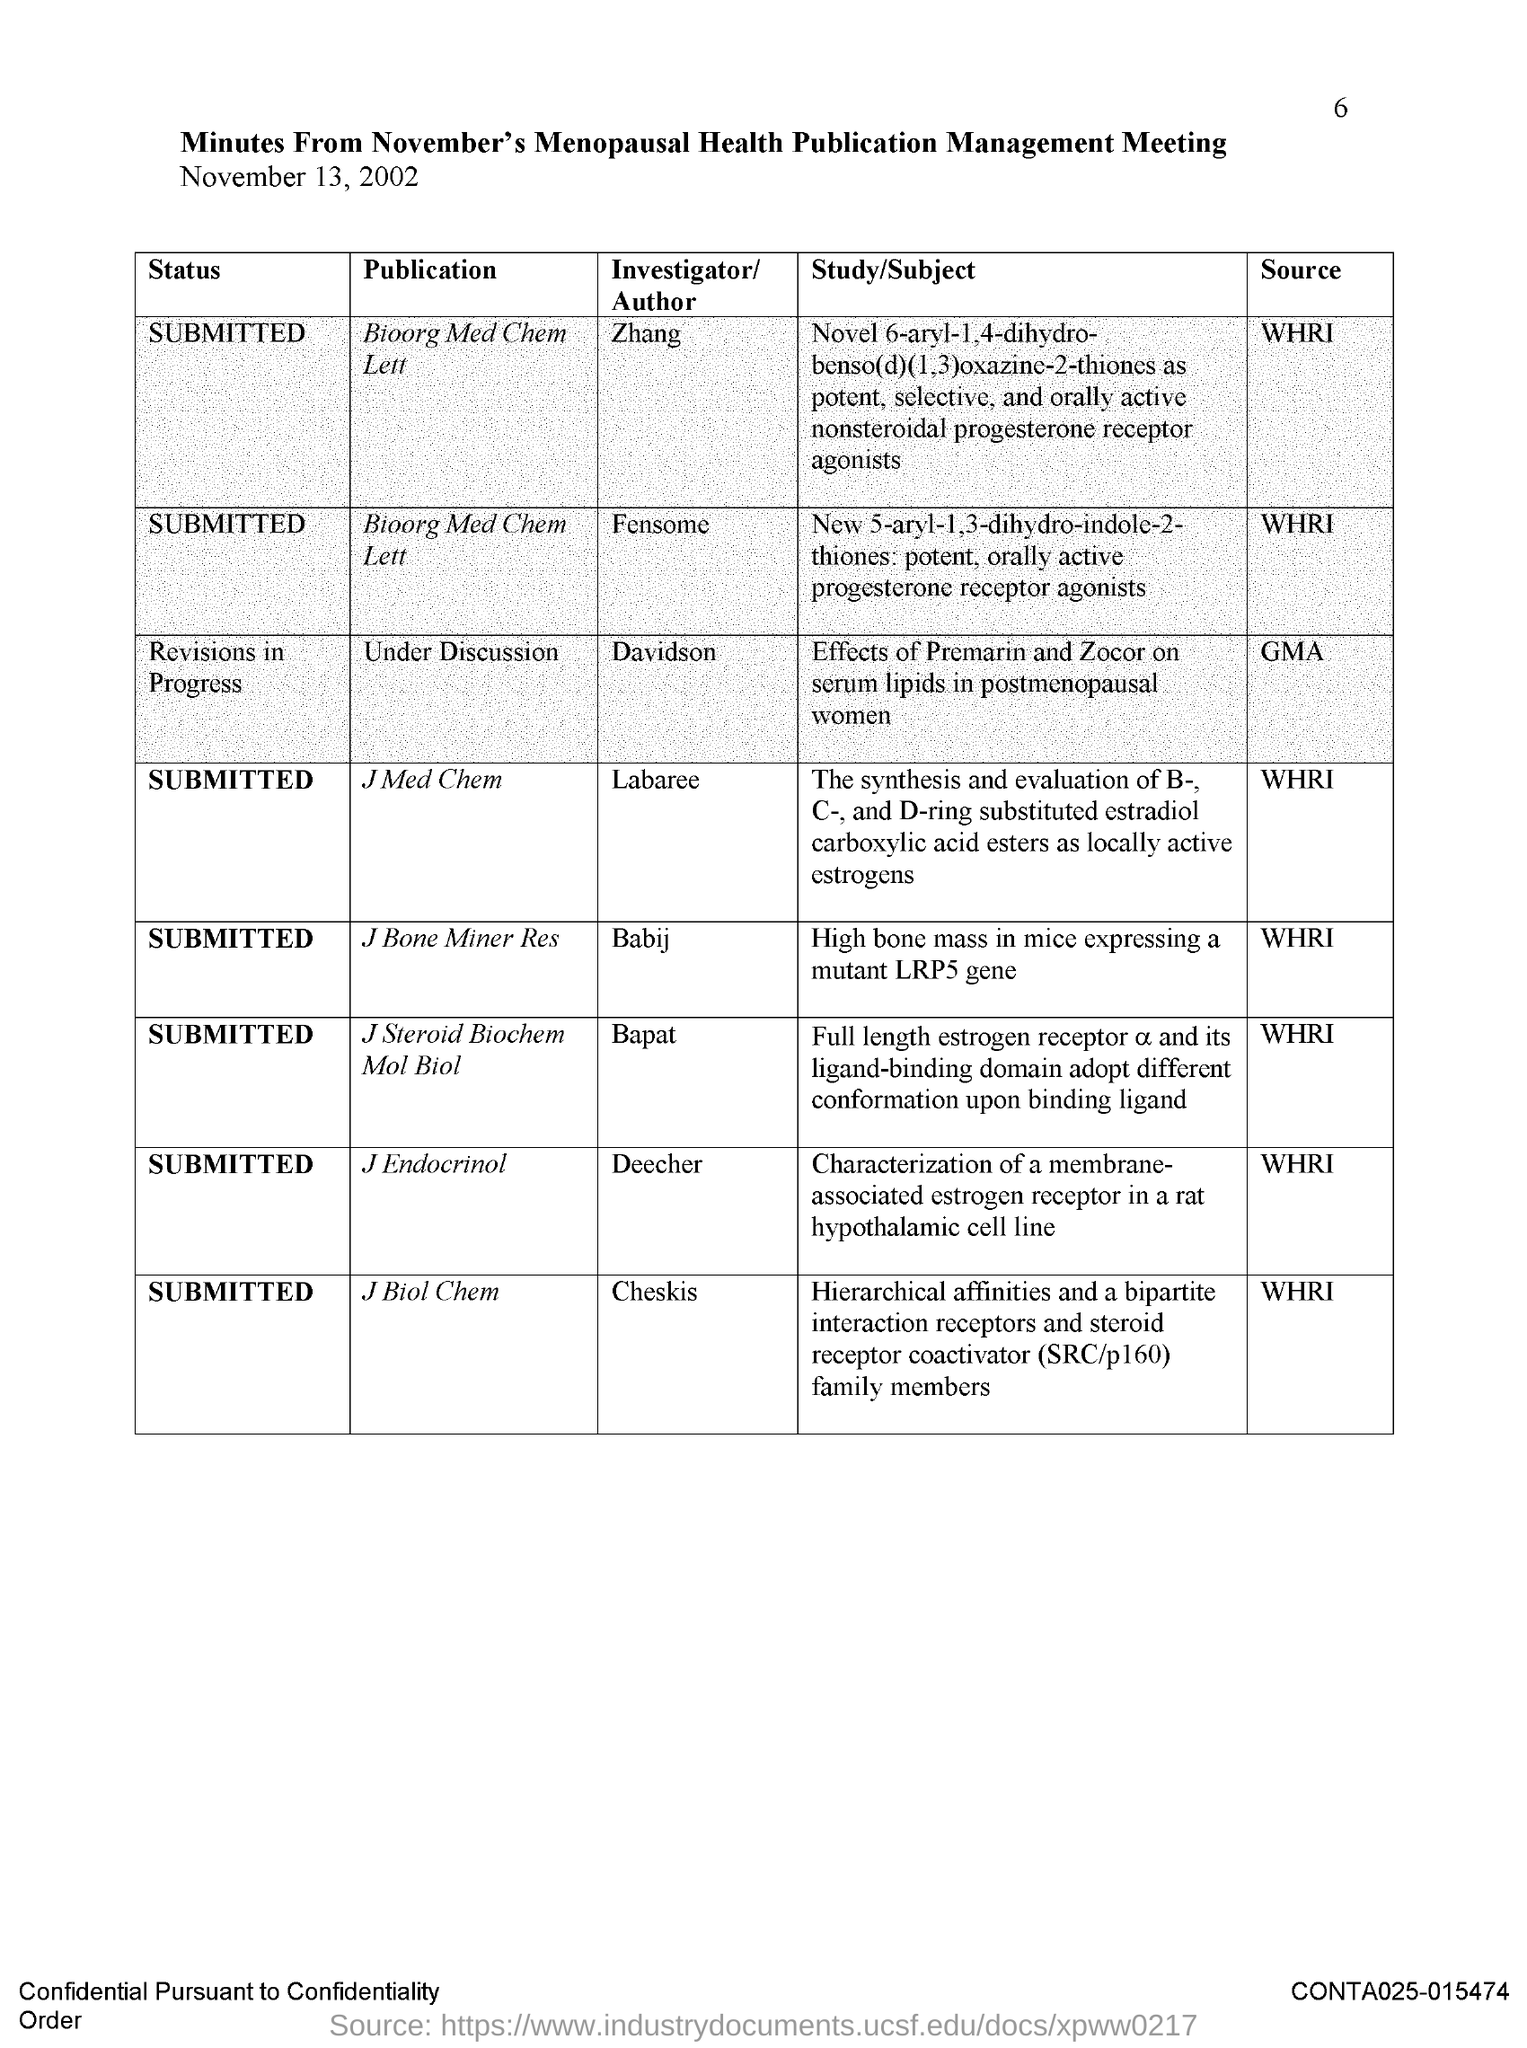Indicate a few pertinent items in this graphic. The title of the document is the minutes from the November meeting of the Menopausal Health Publication Management. The article submitted in J Biol Chem was sourced from WHRI. The date of the meeting is November 13, 2002. The heading for the first column is 'STATUS.' The status of "Journal of Medicinal Chemistry" has been submitted. 